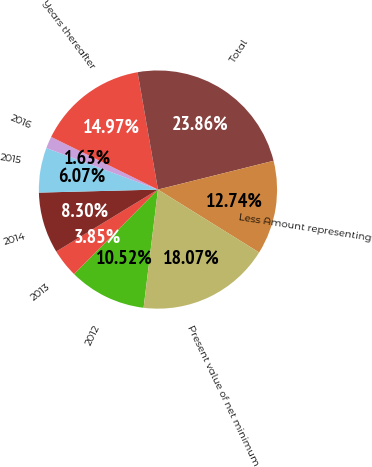Convert chart. <chart><loc_0><loc_0><loc_500><loc_500><pie_chart><fcel>2012<fcel>2013<fcel>2014<fcel>2015<fcel>2016<fcel>Years thereafter<fcel>Total<fcel>Less Amount representing<fcel>Present value of net minimum<nl><fcel>10.52%<fcel>3.85%<fcel>8.3%<fcel>6.07%<fcel>1.63%<fcel>14.97%<fcel>23.86%<fcel>12.74%<fcel>18.07%<nl></chart> 